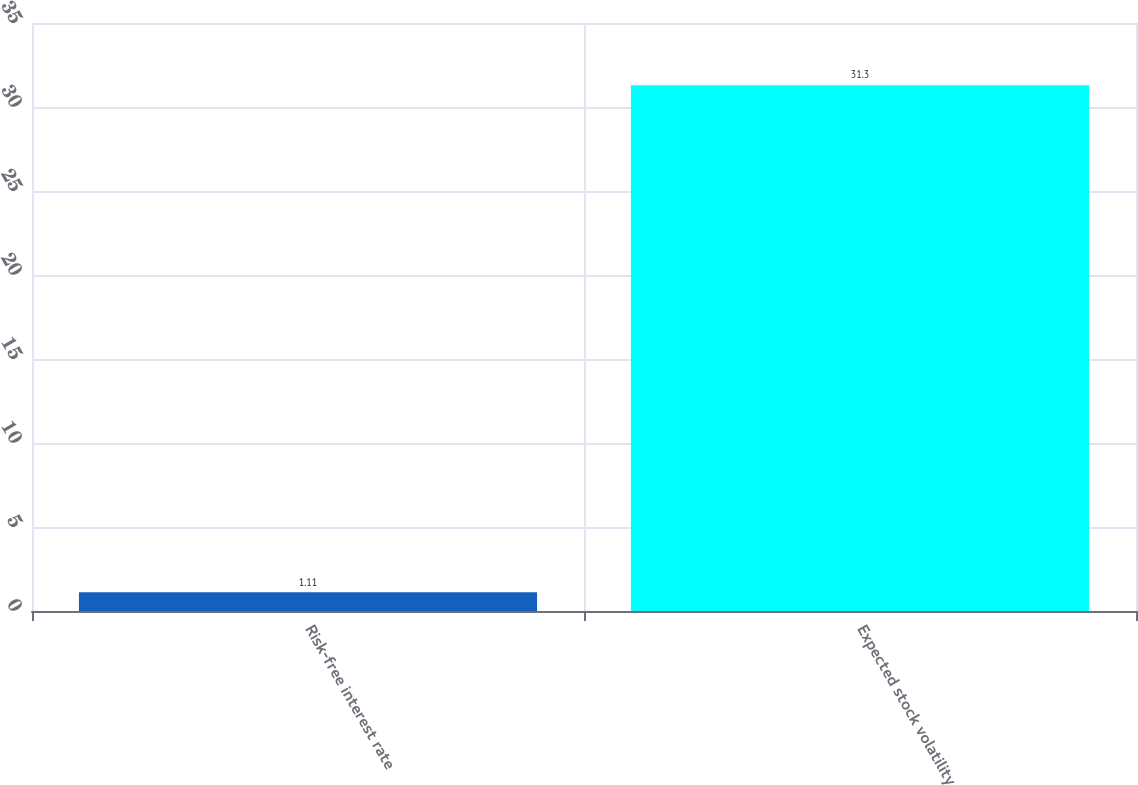Convert chart. <chart><loc_0><loc_0><loc_500><loc_500><bar_chart><fcel>Risk-free interest rate<fcel>Expected stock volatility<nl><fcel>1.11<fcel>31.3<nl></chart> 